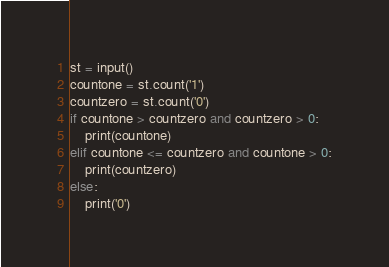<code> <loc_0><loc_0><loc_500><loc_500><_Python_>st = input()
countone = st.count('1')
countzero = st.count('0')
if countone > countzero and countzero > 0:
    print(countone)
elif countone <= countzero and countone > 0:
    print(countzero)
else:
    print('0')</code> 